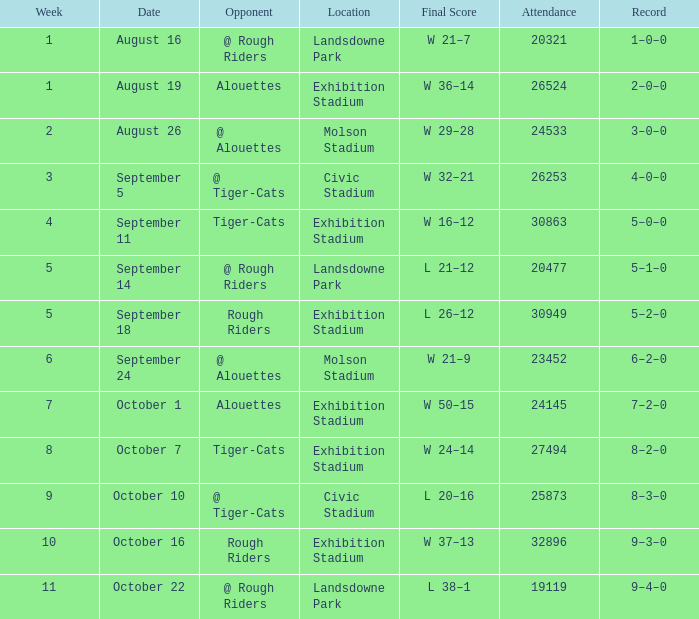How many dates are there in the week that starts with the 4th? 1.0. 